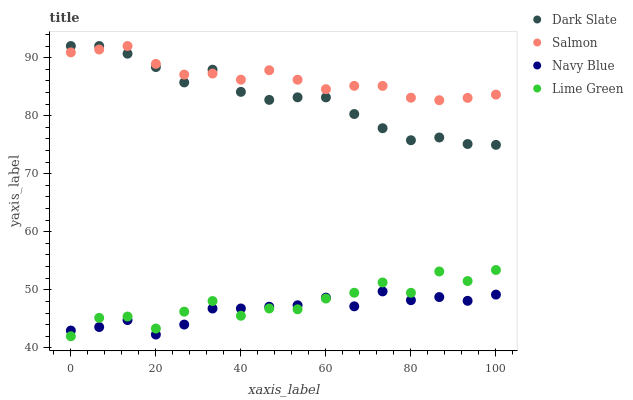Does Navy Blue have the minimum area under the curve?
Answer yes or no. Yes. Does Salmon have the maximum area under the curve?
Answer yes or no. Yes. Does Lime Green have the minimum area under the curve?
Answer yes or no. No. Does Lime Green have the maximum area under the curve?
Answer yes or no. No. Is Salmon the smoothest?
Answer yes or no. Yes. Is Lime Green the roughest?
Answer yes or no. Yes. Is Lime Green the smoothest?
Answer yes or no. No. Is Salmon the roughest?
Answer yes or no. No. Does Lime Green have the lowest value?
Answer yes or no. Yes. Does Salmon have the lowest value?
Answer yes or no. No. Does Salmon have the highest value?
Answer yes or no. Yes. Does Lime Green have the highest value?
Answer yes or no. No. Is Lime Green less than Dark Slate?
Answer yes or no. Yes. Is Dark Slate greater than Lime Green?
Answer yes or no. Yes. Does Salmon intersect Dark Slate?
Answer yes or no. Yes. Is Salmon less than Dark Slate?
Answer yes or no. No. Is Salmon greater than Dark Slate?
Answer yes or no. No. Does Lime Green intersect Dark Slate?
Answer yes or no. No. 